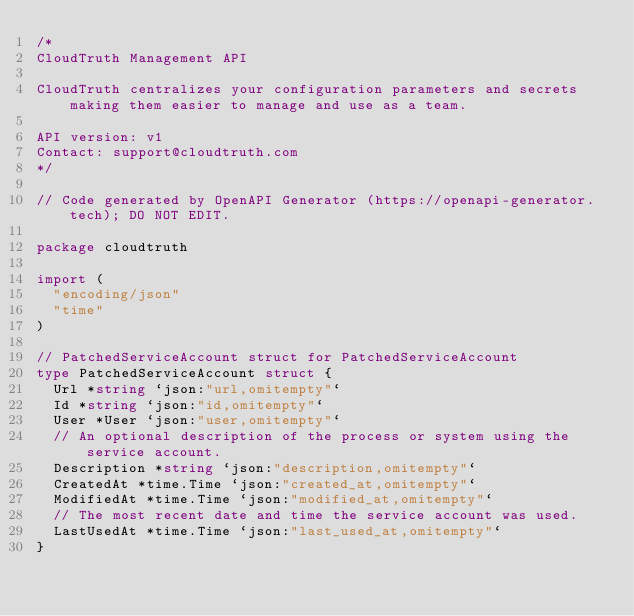<code> <loc_0><loc_0><loc_500><loc_500><_Go_>/*
CloudTruth Management API

CloudTruth centralizes your configuration parameters and secrets making them easier to manage and use as a team.

API version: v1
Contact: support@cloudtruth.com
*/

// Code generated by OpenAPI Generator (https://openapi-generator.tech); DO NOT EDIT.

package cloudtruth

import (
	"encoding/json"
	"time"
)

// PatchedServiceAccount struct for PatchedServiceAccount
type PatchedServiceAccount struct {
	Url *string `json:"url,omitempty"`
	Id *string `json:"id,omitempty"`
	User *User `json:"user,omitempty"`
	// An optional description of the process or system using the service account.
	Description *string `json:"description,omitempty"`
	CreatedAt *time.Time `json:"created_at,omitempty"`
	ModifiedAt *time.Time `json:"modified_at,omitempty"`
	// The most recent date and time the service account was used.
	LastUsedAt *time.Time `json:"last_used_at,omitempty"`
}
</code> 